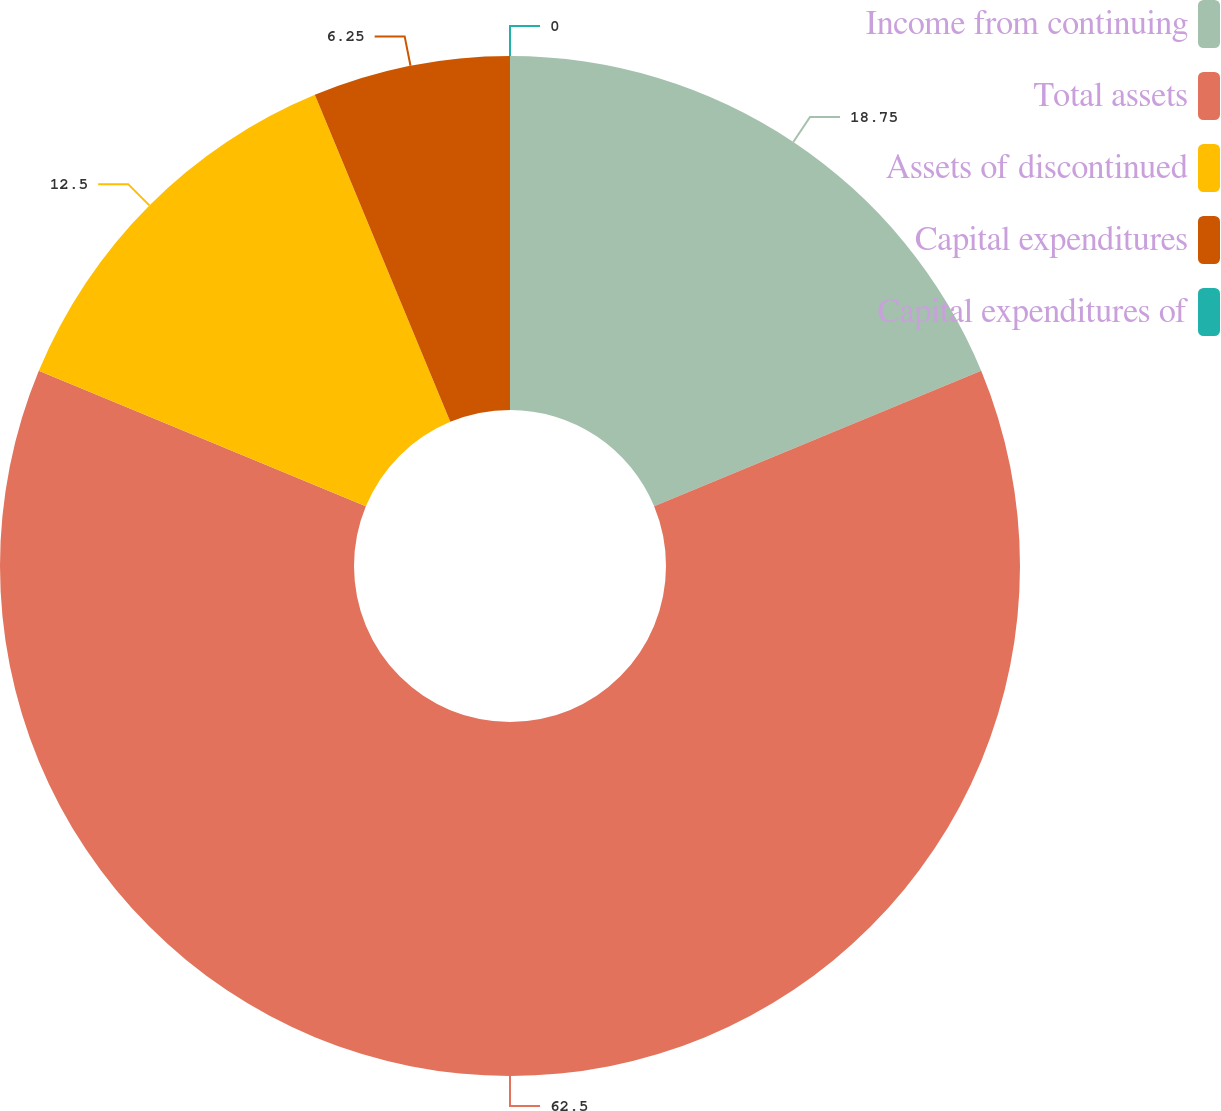Convert chart to OTSL. <chart><loc_0><loc_0><loc_500><loc_500><pie_chart><fcel>Income from continuing<fcel>Total assets<fcel>Assets of discontinued<fcel>Capital expenditures<fcel>Capital expenditures of<nl><fcel>18.75%<fcel>62.5%<fcel>12.5%<fcel>6.25%<fcel>0.0%<nl></chart> 